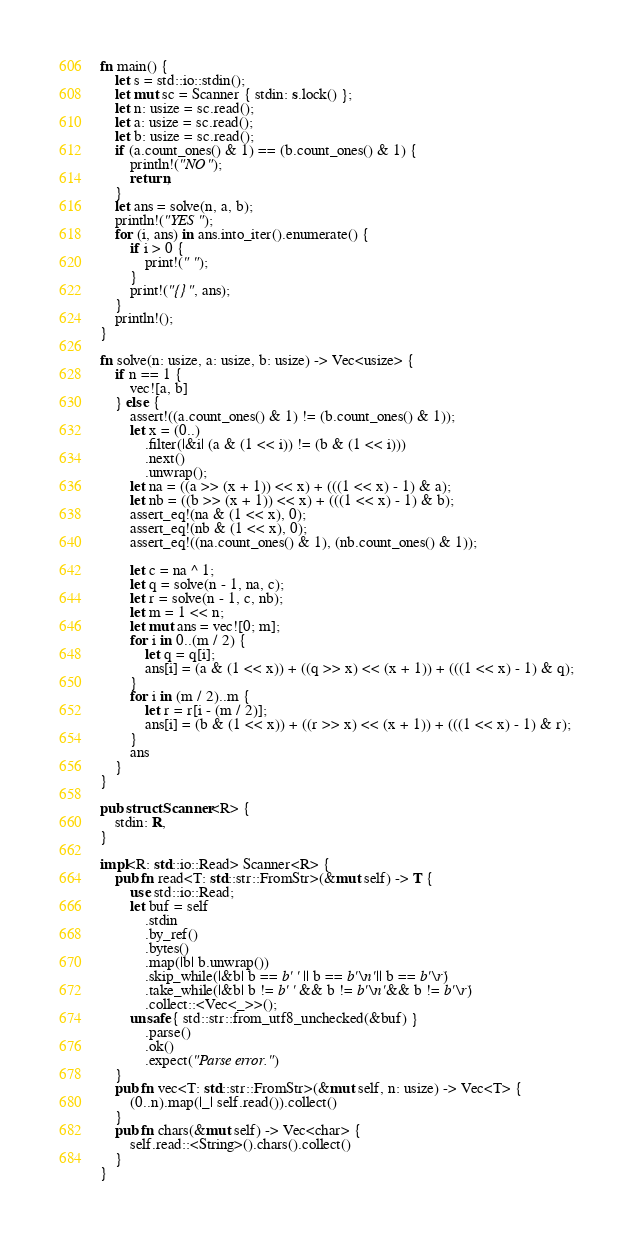Convert code to text. <code><loc_0><loc_0><loc_500><loc_500><_Rust_>fn main() {
    let s = std::io::stdin();
    let mut sc = Scanner { stdin: s.lock() };
    let n: usize = sc.read();
    let a: usize = sc.read();
    let b: usize = sc.read();
    if (a.count_ones() & 1) == (b.count_ones() & 1) {
        println!("NO");
        return;
    }
    let ans = solve(n, a, b);
    println!("YES");
    for (i, ans) in ans.into_iter().enumerate() {
        if i > 0 {
            print!(" ");
        }
        print!("{}", ans);
    }
    println!();
}

fn solve(n: usize, a: usize, b: usize) -> Vec<usize> {
    if n == 1 {
        vec![a, b]
    } else {
        assert!((a.count_ones() & 1) != (b.count_ones() & 1));
        let x = (0..)
            .filter(|&i| (a & (1 << i)) != (b & (1 << i)))
            .next()
            .unwrap();
        let na = ((a >> (x + 1)) << x) + (((1 << x) - 1) & a);
        let nb = ((b >> (x + 1)) << x) + (((1 << x) - 1) & b);
        assert_eq!(na & (1 << x), 0);
        assert_eq!(nb & (1 << x), 0);
        assert_eq!((na.count_ones() & 1), (nb.count_ones() & 1));

        let c = na ^ 1;
        let q = solve(n - 1, na, c);
        let r = solve(n - 1, c, nb);
        let m = 1 << n;
        let mut ans = vec![0; m];
        for i in 0..(m / 2) {
            let q = q[i];
            ans[i] = (a & (1 << x)) + ((q >> x) << (x + 1)) + (((1 << x) - 1) & q);
        }
        for i in (m / 2)..m {
            let r = r[i - (m / 2)];
            ans[i] = (b & (1 << x)) + ((r >> x) << (x + 1)) + (((1 << x) - 1) & r);
        }
        ans
    }
}

pub struct Scanner<R> {
    stdin: R,
}

impl<R: std::io::Read> Scanner<R> {
    pub fn read<T: std::str::FromStr>(&mut self) -> T {
        use std::io::Read;
        let buf = self
            .stdin
            .by_ref()
            .bytes()
            .map(|b| b.unwrap())
            .skip_while(|&b| b == b' ' || b == b'\n' || b == b'\r')
            .take_while(|&b| b != b' ' && b != b'\n' && b != b'\r')
            .collect::<Vec<_>>();
        unsafe { std::str::from_utf8_unchecked(&buf) }
            .parse()
            .ok()
            .expect("Parse error.")
    }
    pub fn vec<T: std::str::FromStr>(&mut self, n: usize) -> Vec<T> {
        (0..n).map(|_| self.read()).collect()
    }
    pub fn chars(&mut self) -> Vec<char> {
        self.read::<String>().chars().collect()
    }
}
</code> 